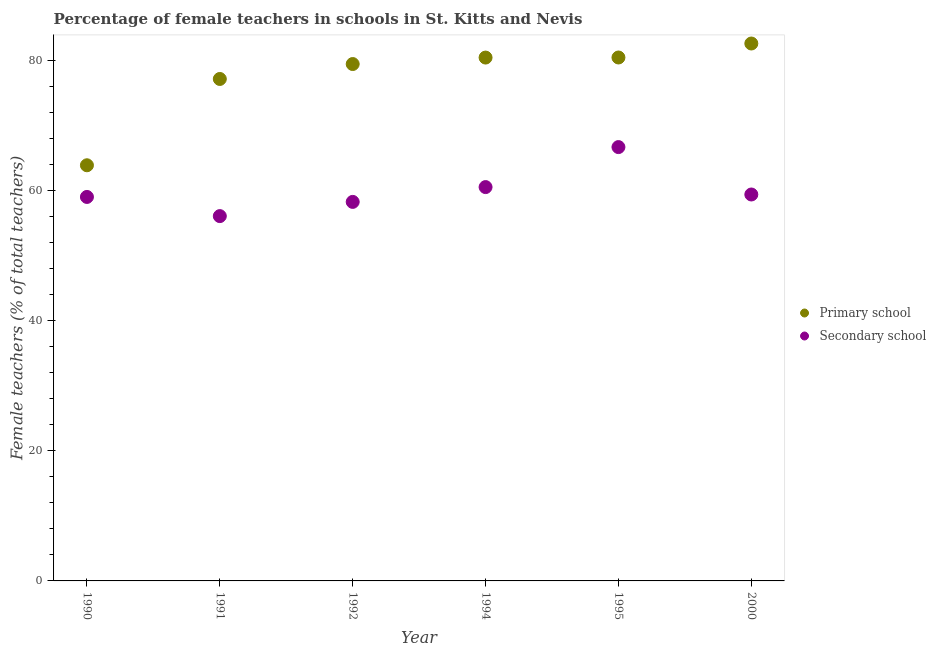What is the percentage of female teachers in secondary schools in 1991?
Give a very brief answer. 56.06. Across all years, what is the maximum percentage of female teachers in secondary schools?
Make the answer very short. 66.67. Across all years, what is the minimum percentage of female teachers in secondary schools?
Provide a short and direct response. 56.06. What is the total percentage of female teachers in primary schools in the graph?
Offer a very short reply. 463.88. What is the difference between the percentage of female teachers in secondary schools in 1990 and that in 2000?
Make the answer very short. -0.38. What is the difference between the percentage of female teachers in primary schools in 1990 and the percentage of female teachers in secondary schools in 1991?
Keep it short and to the point. 7.81. What is the average percentage of female teachers in secondary schools per year?
Provide a succinct answer. 59.98. In the year 1992, what is the difference between the percentage of female teachers in primary schools and percentage of female teachers in secondary schools?
Provide a succinct answer. 21.18. What is the ratio of the percentage of female teachers in secondary schools in 1990 to that in 2000?
Ensure brevity in your answer.  0.99. What is the difference between the highest and the second highest percentage of female teachers in primary schools?
Your answer should be very brief. 2.15. What is the difference between the highest and the lowest percentage of female teachers in primary schools?
Your response must be concise. 18.71. In how many years, is the percentage of female teachers in primary schools greater than the average percentage of female teachers in primary schools taken over all years?
Offer a very short reply. 4. Is the percentage of female teachers in primary schools strictly greater than the percentage of female teachers in secondary schools over the years?
Provide a succinct answer. Yes. How many dotlines are there?
Ensure brevity in your answer.  2. How many years are there in the graph?
Offer a terse response. 6. What is the difference between two consecutive major ticks on the Y-axis?
Provide a short and direct response. 20. Does the graph contain grids?
Offer a terse response. No. How are the legend labels stacked?
Offer a terse response. Vertical. What is the title of the graph?
Give a very brief answer. Percentage of female teachers in schools in St. Kitts and Nevis. What is the label or title of the X-axis?
Provide a succinct answer. Year. What is the label or title of the Y-axis?
Make the answer very short. Female teachers (% of total teachers). What is the Female teachers (% of total teachers) of Primary school in 1990?
Give a very brief answer. 63.87. What is the Female teachers (% of total teachers) of Secondary school in 1990?
Ensure brevity in your answer.  59.01. What is the Female teachers (% of total teachers) of Primary school in 1991?
Your answer should be very brief. 77.13. What is the Female teachers (% of total teachers) in Secondary school in 1991?
Offer a terse response. 56.06. What is the Female teachers (% of total teachers) in Primary school in 1992?
Your response must be concise. 79.43. What is the Female teachers (% of total teachers) of Secondary school in 1992?
Provide a short and direct response. 58.24. What is the Female teachers (% of total teachers) of Primary school in 1994?
Your answer should be compact. 80.42. What is the Female teachers (% of total teachers) in Secondary school in 1994?
Make the answer very short. 60.52. What is the Female teachers (% of total teachers) in Primary school in 1995?
Keep it short and to the point. 80.43. What is the Female teachers (% of total teachers) in Secondary school in 1995?
Your response must be concise. 66.67. What is the Female teachers (% of total teachers) of Primary school in 2000?
Keep it short and to the point. 82.58. What is the Female teachers (% of total teachers) of Secondary school in 2000?
Your response must be concise. 59.38. Across all years, what is the maximum Female teachers (% of total teachers) in Primary school?
Your answer should be very brief. 82.58. Across all years, what is the maximum Female teachers (% of total teachers) of Secondary school?
Your answer should be compact. 66.67. Across all years, what is the minimum Female teachers (% of total teachers) in Primary school?
Your answer should be compact. 63.87. Across all years, what is the minimum Female teachers (% of total teachers) in Secondary school?
Offer a very short reply. 56.06. What is the total Female teachers (% of total teachers) in Primary school in the graph?
Your answer should be compact. 463.88. What is the total Female teachers (% of total teachers) in Secondary school in the graph?
Provide a short and direct response. 359.88. What is the difference between the Female teachers (% of total teachers) in Primary school in 1990 and that in 1991?
Provide a succinct answer. -13.26. What is the difference between the Female teachers (% of total teachers) in Secondary school in 1990 and that in 1991?
Give a very brief answer. 2.95. What is the difference between the Female teachers (% of total teachers) in Primary school in 1990 and that in 1992?
Provide a short and direct response. -15.56. What is the difference between the Female teachers (% of total teachers) in Secondary school in 1990 and that in 1992?
Provide a short and direct response. 0.76. What is the difference between the Female teachers (% of total teachers) in Primary school in 1990 and that in 1994?
Offer a terse response. -16.55. What is the difference between the Female teachers (% of total teachers) of Secondary school in 1990 and that in 1994?
Provide a short and direct response. -1.51. What is the difference between the Female teachers (% of total teachers) of Primary school in 1990 and that in 1995?
Keep it short and to the point. -16.56. What is the difference between the Female teachers (% of total teachers) in Secondary school in 1990 and that in 1995?
Your response must be concise. -7.66. What is the difference between the Female teachers (% of total teachers) in Primary school in 1990 and that in 2000?
Provide a short and direct response. -18.71. What is the difference between the Female teachers (% of total teachers) in Secondary school in 1990 and that in 2000?
Offer a terse response. -0.38. What is the difference between the Female teachers (% of total teachers) in Primary school in 1991 and that in 1992?
Make the answer very short. -2.29. What is the difference between the Female teachers (% of total teachers) in Secondary school in 1991 and that in 1992?
Offer a very short reply. -2.18. What is the difference between the Female teachers (% of total teachers) in Primary school in 1991 and that in 1994?
Offer a very short reply. -3.29. What is the difference between the Female teachers (% of total teachers) of Secondary school in 1991 and that in 1994?
Keep it short and to the point. -4.46. What is the difference between the Female teachers (% of total teachers) in Primary school in 1991 and that in 1995?
Provide a short and direct response. -3.3. What is the difference between the Female teachers (% of total teachers) of Secondary school in 1991 and that in 1995?
Offer a terse response. -10.61. What is the difference between the Female teachers (% of total teachers) in Primary school in 1991 and that in 2000?
Make the answer very short. -5.45. What is the difference between the Female teachers (% of total teachers) in Secondary school in 1991 and that in 2000?
Your answer should be very brief. -3.32. What is the difference between the Female teachers (% of total teachers) of Primary school in 1992 and that in 1994?
Keep it short and to the point. -0.99. What is the difference between the Female teachers (% of total teachers) in Secondary school in 1992 and that in 1994?
Give a very brief answer. -2.28. What is the difference between the Female teachers (% of total teachers) in Primary school in 1992 and that in 1995?
Offer a terse response. -1.01. What is the difference between the Female teachers (% of total teachers) of Secondary school in 1992 and that in 1995?
Provide a short and direct response. -8.42. What is the difference between the Female teachers (% of total teachers) of Primary school in 1992 and that in 2000?
Give a very brief answer. -3.16. What is the difference between the Female teachers (% of total teachers) in Secondary school in 1992 and that in 2000?
Ensure brevity in your answer.  -1.14. What is the difference between the Female teachers (% of total teachers) of Primary school in 1994 and that in 1995?
Make the answer very short. -0.01. What is the difference between the Female teachers (% of total teachers) of Secondary school in 1994 and that in 1995?
Your answer should be very brief. -6.15. What is the difference between the Female teachers (% of total teachers) in Primary school in 1994 and that in 2000?
Provide a succinct answer. -2.16. What is the difference between the Female teachers (% of total teachers) in Secondary school in 1994 and that in 2000?
Give a very brief answer. 1.14. What is the difference between the Female teachers (% of total teachers) of Primary school in 1995 and that in 2000?
Offer a very short reply. -2.15. What is the difference between the Female teachers (% of total teachers) of Secondary school in 1995 and that in 2000?
Your answer should be very brief. 7.28. What is the difference between the Female teachers (% of total teachers) of Primary school in 1990 and the Female teachers (% of total teachers) of Secondary school in 1991?
Offer a very short reply. 7.81. What is the difference between the Female teachers (% of total teachers) of Primary school in 1990 and the Female teachers (% of total teachers) of Secondary school in 1992?
Your response must be concise. 5.63. What is the difference between the Female teachers (% of total teachers) of Primary school in 1990 and the Female teachers (% of total teachers) of Secondary school in 1994?
Your answer should be very brief. 3.35. What is the difference between the Female teachers (% of total teachers) in Primary school in 1990 and the Female teachers (% of total teachers) in Secondary school in 1995?
Make the answer very short. -2.79. What is the difference between the Female teachers (% of total teachers) in Primary school in 1990 and the Female teachers (% of total teachers) in Secondary school in 2000?
Provide a short and direct response. 4.49. What is the difference between the Female teachers (% of total teachers) in Primary school in 1991 and the Female teachers (% of total teachers) in Secondary school in 1992?
Your answer should be compact. 18.89. What is the difference between the Female teachers (% of total teachers) in Primary school in 1991 and the Female teachers (% of total teachers) in Secondary school in 1994?
Provide a succinct answer. 16.61. What is the difference between the Female teachers (% of total teachers) in Primary school in 1991 and the Female teachers (% of total teachers) in Secondary school in 1995?
Your answer should be very brief. 10.47. What is the difference between the Female teachers (% of total teachers) of Primary school in 1991 and the Female teachers (% of total teachers) of Secondary school in 2000?
Provide a short and direct response. 17.75. What is the difference between the Female teachers (% of total teachers) in Primary school in 1992 and the Female teachers (% of total teachers) in Secondary school in 1994?
Give a very brief answer. 18.91. What is the difference between the Female teachers (% of total teachers) in Primary school in 1992 and the Female teachers (% of total teachers) in Secondary school in 1995?
Make the answer very short. 12.76. What is the difference between the Female teachers (% of total teachers) of Primary school in 1992 and the Female teachers (% of total teachers) of Secondary school in 2000?
Provide a short and direct response. 20.05. What is the difference between the Female teachers (% of total teachers) in Primary school in 1994 and the Female teachers (% of total teachers) in Secondary school in 1995?
Offer a terse response. 13.76. What is the difference between the Female teachers (% of total teachers) in Primary school in 1994 and the Female teachers (% of total teachers) in Secondary school in 2000?
Your answer should be compact. 21.04. What is the difference between the Female teachers (% of total teachers) of Primary school in 1995 and the Female teachers (% of total teachers) of Secondary school in 2000?
Make the answer very short. 21.05. What is the average Female teachers (% of total teachers) of Primary school per year?
Ensure brevity in your answer.  77.31. What is the average Female teachers (% of total teachers) in Secondary school per year?
Offer a very short reply. 59.98. In the year 1990, what is the difference between the Female teachers (% of total teachers) of Primary school and Female teachers (% of total teachers) of Secondary school?
Make the answer very short. 4.87. In the year 1991, what is the difference between the Female teachers (% of total teachers) in Primary school and Female teachers (% of total teachers) in Secondary school?
Provide a short and direct response. 21.07. In the year 1992, what is the difference between the Female teachers (% of total teachers) in Primary school and Female teachers (% of total teachers) in Secondary school?
Make the answer very short. 21.18. In the year 1994, what is the difference between the Female teachers (% of total teachers) of Primary school and Female teachers (% of total teachers) of Secondary school?
Keep it short and to the point. 19.9. In the year 1995, what is the difference between the Female teachers (% of total teachers) of Primary school and Female teachers (% of total teachers) of Secondary school?
Your answer should be compact. 13.77. In the year 2000, what is the difference between the Female teachers (% of total teachers) in Primary school and Female teachers (% of total teachers) in Secondary school?
Provide a short and direct response. 23.2. What is the ratio of the Female teachers (% of total teachers) of Primary school in 1990 to that in 1991?
Your answer should be compact. 0.83. What is the ratio of the Female teachers (% of total teachers) of Secondary school in 1990 to that in 1991?
Your answer should be very brief. 1.05. What is the ratio of the Female teachers (% of total teachers) in Primary school in 1990 to that in 1992?
Provide a short and direct response. 0.8. What is the ratio of the Female teachers (% of total teachers) of Secondary school in 1990 to that in 1992?
Ensure brevity in your answer.  1.01. What is the ratio of the Female teachers (% of total teachers) in Primary school in 1990 to that in 1994?
Your answer should be very brief. 0.79. What is the ratio of the Female teachers (% of total teachers) of Secondary school in 1990 to that in 1994?
Provide a succinct answer. 0.97. What is the ratio of the Female teachers (% of total teachers) of Primary school in 1990 to that in 1995?
Your response must be concise. 0.79. What is the ratio of the Female teachers (% of total teachers) of Secondary school in 1990 to that in 1995?
Ensure brevity in your answer.  0.89. What is the ratio of the Female teachers (% of total teachers) in Primary school in 1990 to that in 2000?
Offer a terse response. 0.77. What is the ratio of the Female teachers (% of total teachers) in Secondary school in 1990 to that in 2000?
Give a very brief answer. 0.99. What is the ratio of the Female teachers (% of total teachers) in Primary school in 1991 to that in 1992?
Ensure brevity in your answer.  0.97. What is the ratio of the Female teachers (% of total teachers) in Secondary school in 1991 to that in 1992?
Ensure brevity in your answer.  0.96. What is the ratio of the Female teachers (% of total teachers) in Primary school in 1991 to that in 1994?
Keep it short and to the point. 0.96. What is the ratio of the Female teachers (% of total teachers) in Secondary school in 1991 to that in 1994?
Make the answer very short. 0.93. What is the ratio of the Female teachers (% of total teachers) in Secondary school in 1991 to that in 1995?
Make the answer very short. 0.84. What is the ratio of the Female teachers (% of total teachers) in Primary school in 1991 to that in 2000?
Ensure brevity in your answer.  0.93. What is the ratio of the Female teachers (% of total teachers) of Secondary school in 1991 to that in 2000?
Provide a short and direct response. 0.94. What is the ratio of the Female teachers (% of total teachers) in Primary school in 1992 to that in 1994?
Your response must be concise. 0.99. What is the ratio of the Female teachers (% of total teachers) of Secondary school in 1992 to that in 1994?
Keep it short and to the point. 0.96. What is the ratio of the Female teachers (% of total teachers) in Primary school in 1992 to that in 1995?
Keep it short and to the point. 0.99. What is the ratio of the Female teachers (% of total teachers) of Secondary school in 1992 to that in 1995?
Make the answer very short. 0.87. What is the ratio of the Female teachers (% of total teachers) in Primary school in 1992 to that in 2000?
Keep it short and to the point. 0.96. What is the ratio of the Female teachers (% of total teachers) in Secondary school in 1992 to that in 2000?
Keep it short and to the point. 0.98. What is the ratio of the Female teachers (% of total teachers) of Primary school in 1994 to that in 1995?
Your answer should be very brief. 1. What is the ratio of the Female teachers (% of total teachers) of Secondary school in 1994 to that in 1995?
Provide a short and direct response. 0.91. What is the ratio of the Female teachers (% of total teachers) in Primary school in 1994 to that in 2000?
Your response must be concise. 0.97. What is the ratio of the Female teachers (% of total teachers) in Secondary school in 1994 to that in 2000?
Give a very brief answer. 1.02. What is the ratio of the Female teachers (% of total teachers) of Primary school in 1995 to that in 2000?
Offer a very short reply. 0.97. What is the ratio of the Female teachers (% of total teachers) of Secondary school in 1995 to that in 2000?
Your answer should be compact. 1.12. What is the difference between the highest and the second highest Female teachers (% of total teachers) in Primary school?
Give a very brief answer. 2.15. What is the difference between the highest and the second highest Female teachers (% of total teachers) in Secondary school?
Give a very brief answer. 6.15. What is the difference between the highest and the lowest Female teachers (% of total teachers) of Primary school?
Ensure brevity in your answer.  18.71. What is the difference between the highest and the lowest Female teachers (% of total teachers) of Secondary school?
Offer a terse response. 10.61. 